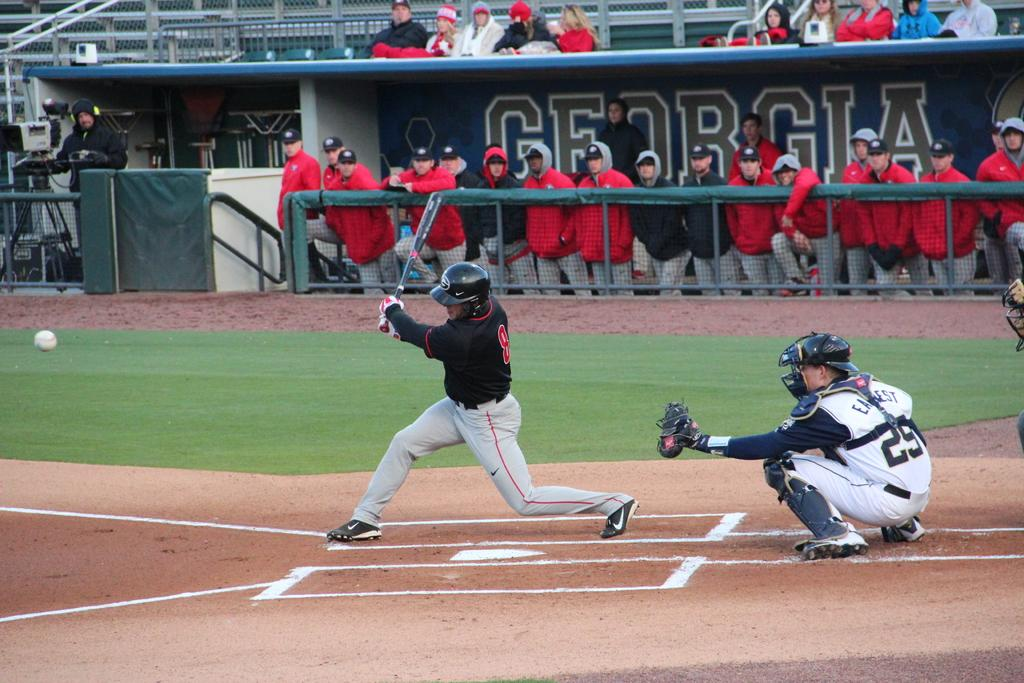<image>
Offer a succinct explanation of the picture presented. One of the presented sports teams is from Georgia. 